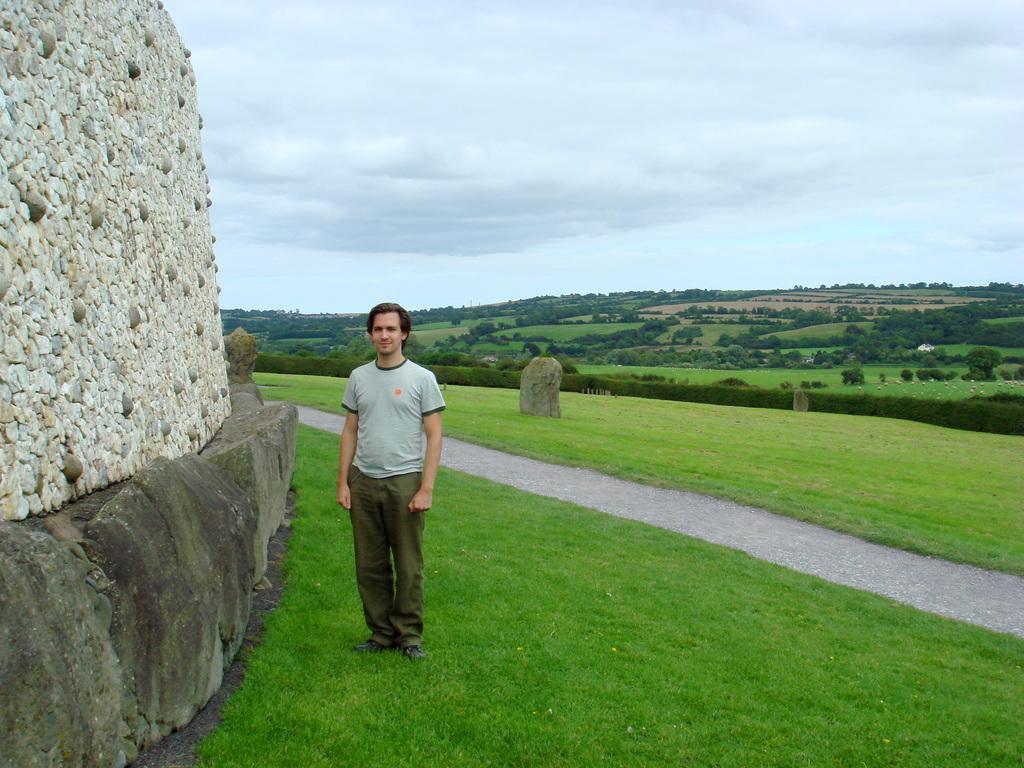In one or two sentences, can you explain what this image depicts? This is an outside view. On the right side there is a path. On both sides of the path, I can see the grass. On the left side there is a rock and a wall. Beside this a man is standing, smiling and giving pose for the picture. In the background there are many trees. At the top of the image I can see the sky and clouds. 